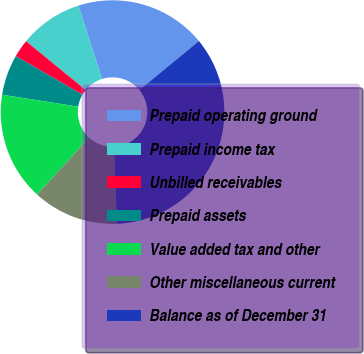<chart> <loc_0><loc_0><loc_500><loc_500><pie_chart><fcel>Prepaid operating ground<fcel>Prepaid income tax<fcel>Unbilled receivables<fcel>Prepaid assets<fcel>Value added tax and other<fcel>Other miscellaneous current<fcel>Balance as of December 31<nl><fcel>18.97%<fcel>9.14%<fcel>2.59%<fcel>5.86%<fcel>15.69%<fcel>12.41%<fcel>35.35%<nl></chart> 